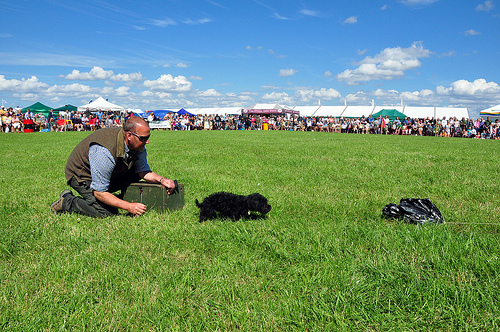<image>
Is there a man next to the box? Yes. The man is positioned adjacent to the box, located nearby in the same general area. Is there a dog in front of the guy? Yes. The dog is positioned in front of the guy, appearing closer to the camera viewpoint. 